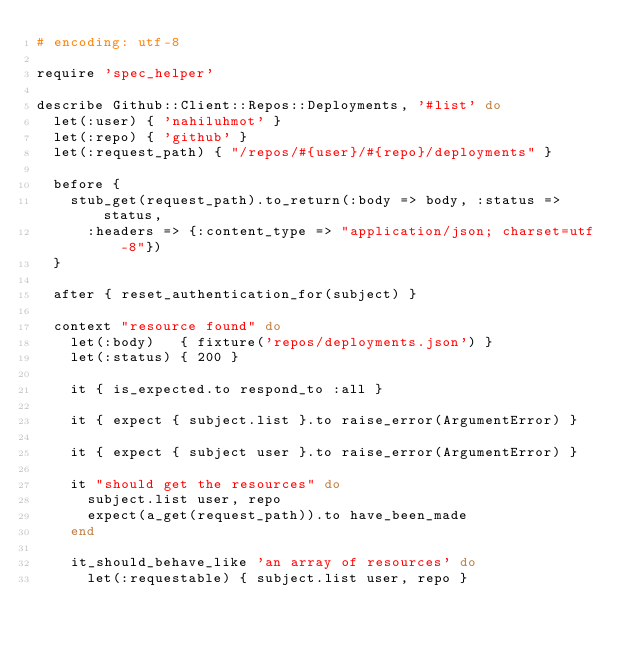Convert code to text. <code><loc_0><loc_0><loc_500><loc_500><_Ruby_># encoding: utf-8

require 'spec_helper'

describe Github::Client::Repos::Deployments, '#list' do
  let(:user) { 'nahiluhmot' }
  let(:repo) { 'github' }
  let(:request_path) { "/repos/#{user}/#{repo}/deployments" }

  before {
    stub_get(request_path).to_return(:body => body, :status => status,
      :headers => {:content_type => "application/json; charset=utf-8"})
  }

  after { reset_authentication_for(subject) }

  context "resource found" do
    let(:body)   { fixture('repos/deployments.json') }
    let(:status) { 200 }

    it { is_expected.to respond_to :all }

    it { expect { subject.list }.to raise_error(ArgumentError) }

    it { expect { subject user }.to raise_error(ArgumentError) }

    it "should get the resources" do
      subject.list user, repo
      expect(a_get(request_path)).to have_been_made
    end

    it_should_behave_like 'an array of resources' do
      let(:requestable) { subject.list user, repo }</code> 